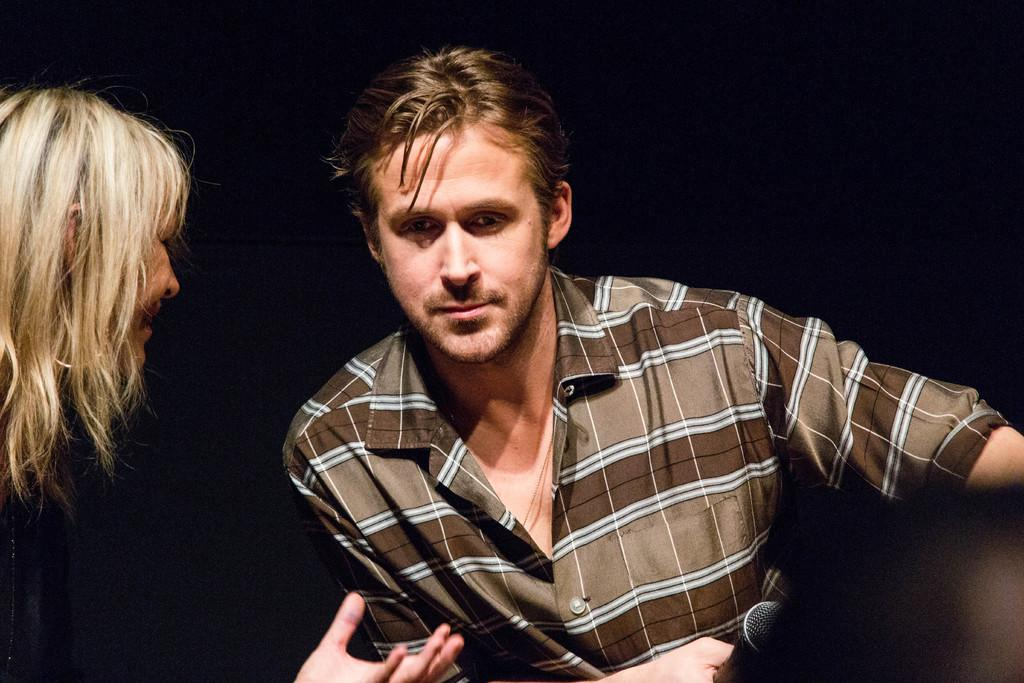How many people are sitting in the image? There are two people sitting in the image. What are the people doing in the image? Both people are looking in the same direction. What is the person on the right side holding? The person on the right side is holding a microphone. What can be observed about the lighting in the image? The background of the image is dark. What type of bed can be seen in the image? There is no bed present in the image. How comfortable is the chair the person on the left side is sitting on? The image does not provide information about the comfort level of the chair, as it only shows the people sitting and their actions. 